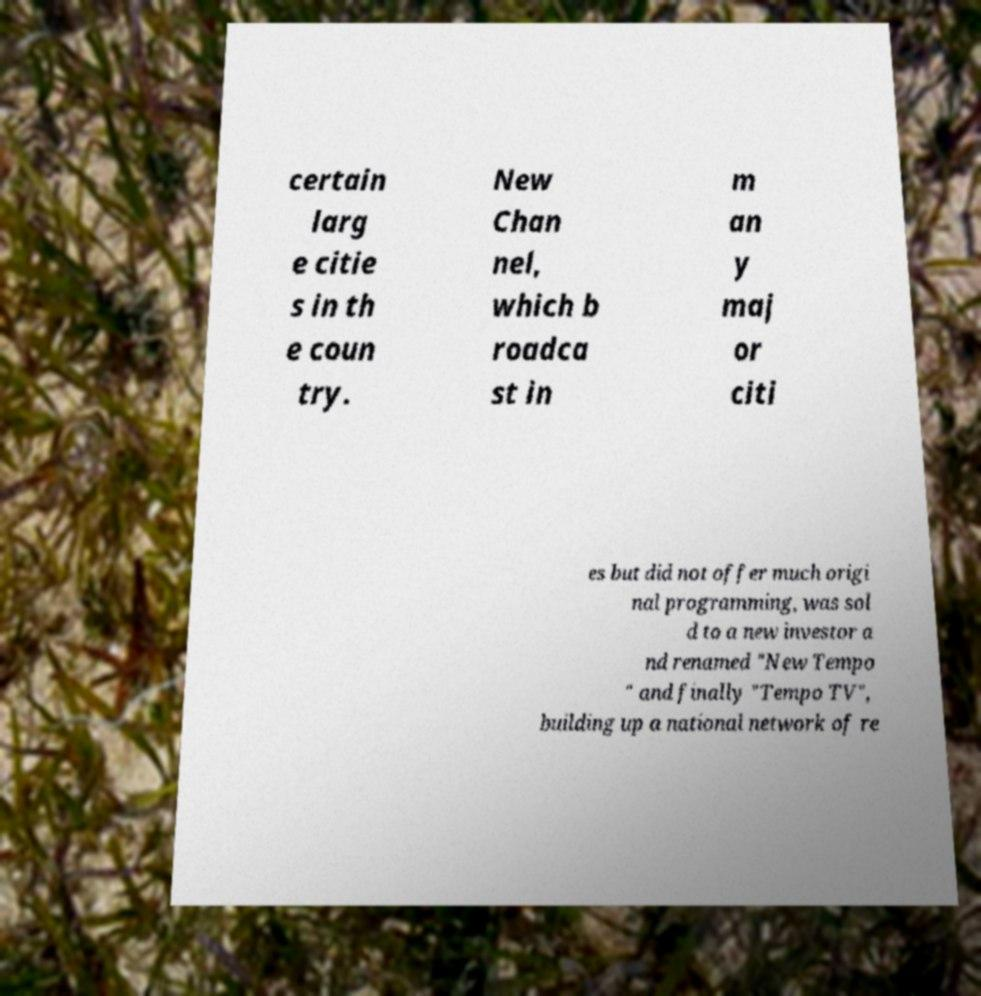There's text embedded in this image that I need extracted. Can you transcribe it verbatim? certain larg e citie s in th e coun try. New Chan nel, which b roadca st in m an y maj or citi es but did not offer much origi nal programming, was sol d to a new investor a nd renamed "New Tempo " and finally "Tempo TV", building up a national network of re 